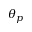<formula> <loc_0><loc_0><loc_500><loc_500>\theta _ { p }</formula> 